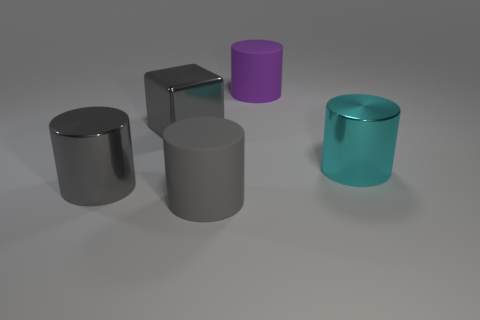What number of objects are large purple cylinders or things that are right of the large purple thing?
Ensure brevity in your answer.  2. Is there a shiny cylinder that has the same color as the big shiny block?
Offer a terse response. Yes. How many gray things are objects or large matte objects?
Offer a terse response. 3. What number of other things are there of the same size as the gray metallic cylinder?
Offer a terse response. 4. What number of large things are gray cylinders or gray shiny cylinders?
Provide a short and direct response. 2. Is the size of the metallic block the same as the metallic thing that is in front of the cyan metal object?
Your response must be concise. Yes. What is the shape of the gray object that is the same material as the purple cylinder?
Your response must be concise. Cylinder. Is there a purple metallic ball?
Provide a succinct answer. No. Is the number of large metal cubes that are in front of the gray metallic block less than the number of gray metal blocks on the right side of the cyan object?
Give a very brief answer. No. What shape is the metallic thing to the right of the purple cylinder?
Your answer should be very brief. Cylinder. 